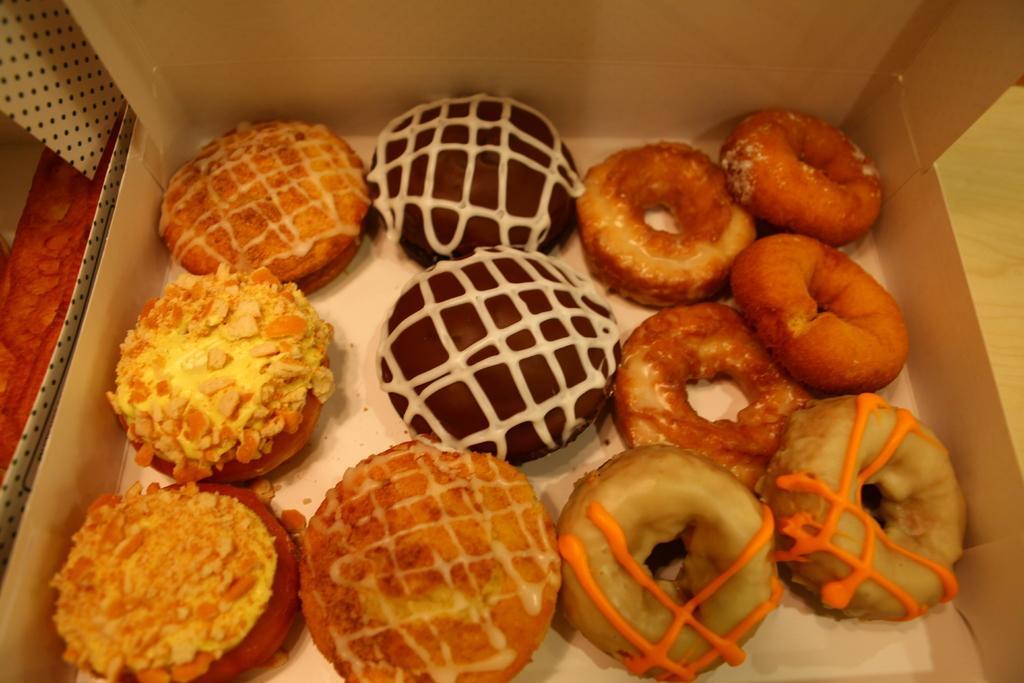Please provide a concise description of this image. In this image I can see different food items kept in an opened box made up of cardboard on a table.  